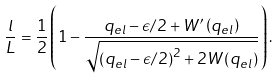<formula> <loc_0><loc_0><loc_500><loc_500>\frac { l } { L } = \frac { 1 } { 2 } \left ( 1 - \frac { q _ { e l } - \epsilon / 2 + W ^ { \prime } \left ( q _ { e l } \right ) } { \sqrt { \left ( q _ { e l } - \epsilon / 2 \right ) ^ { 2 } + 2 W \left ( q _ { e l } \right ) } } \right ) .</formula> 